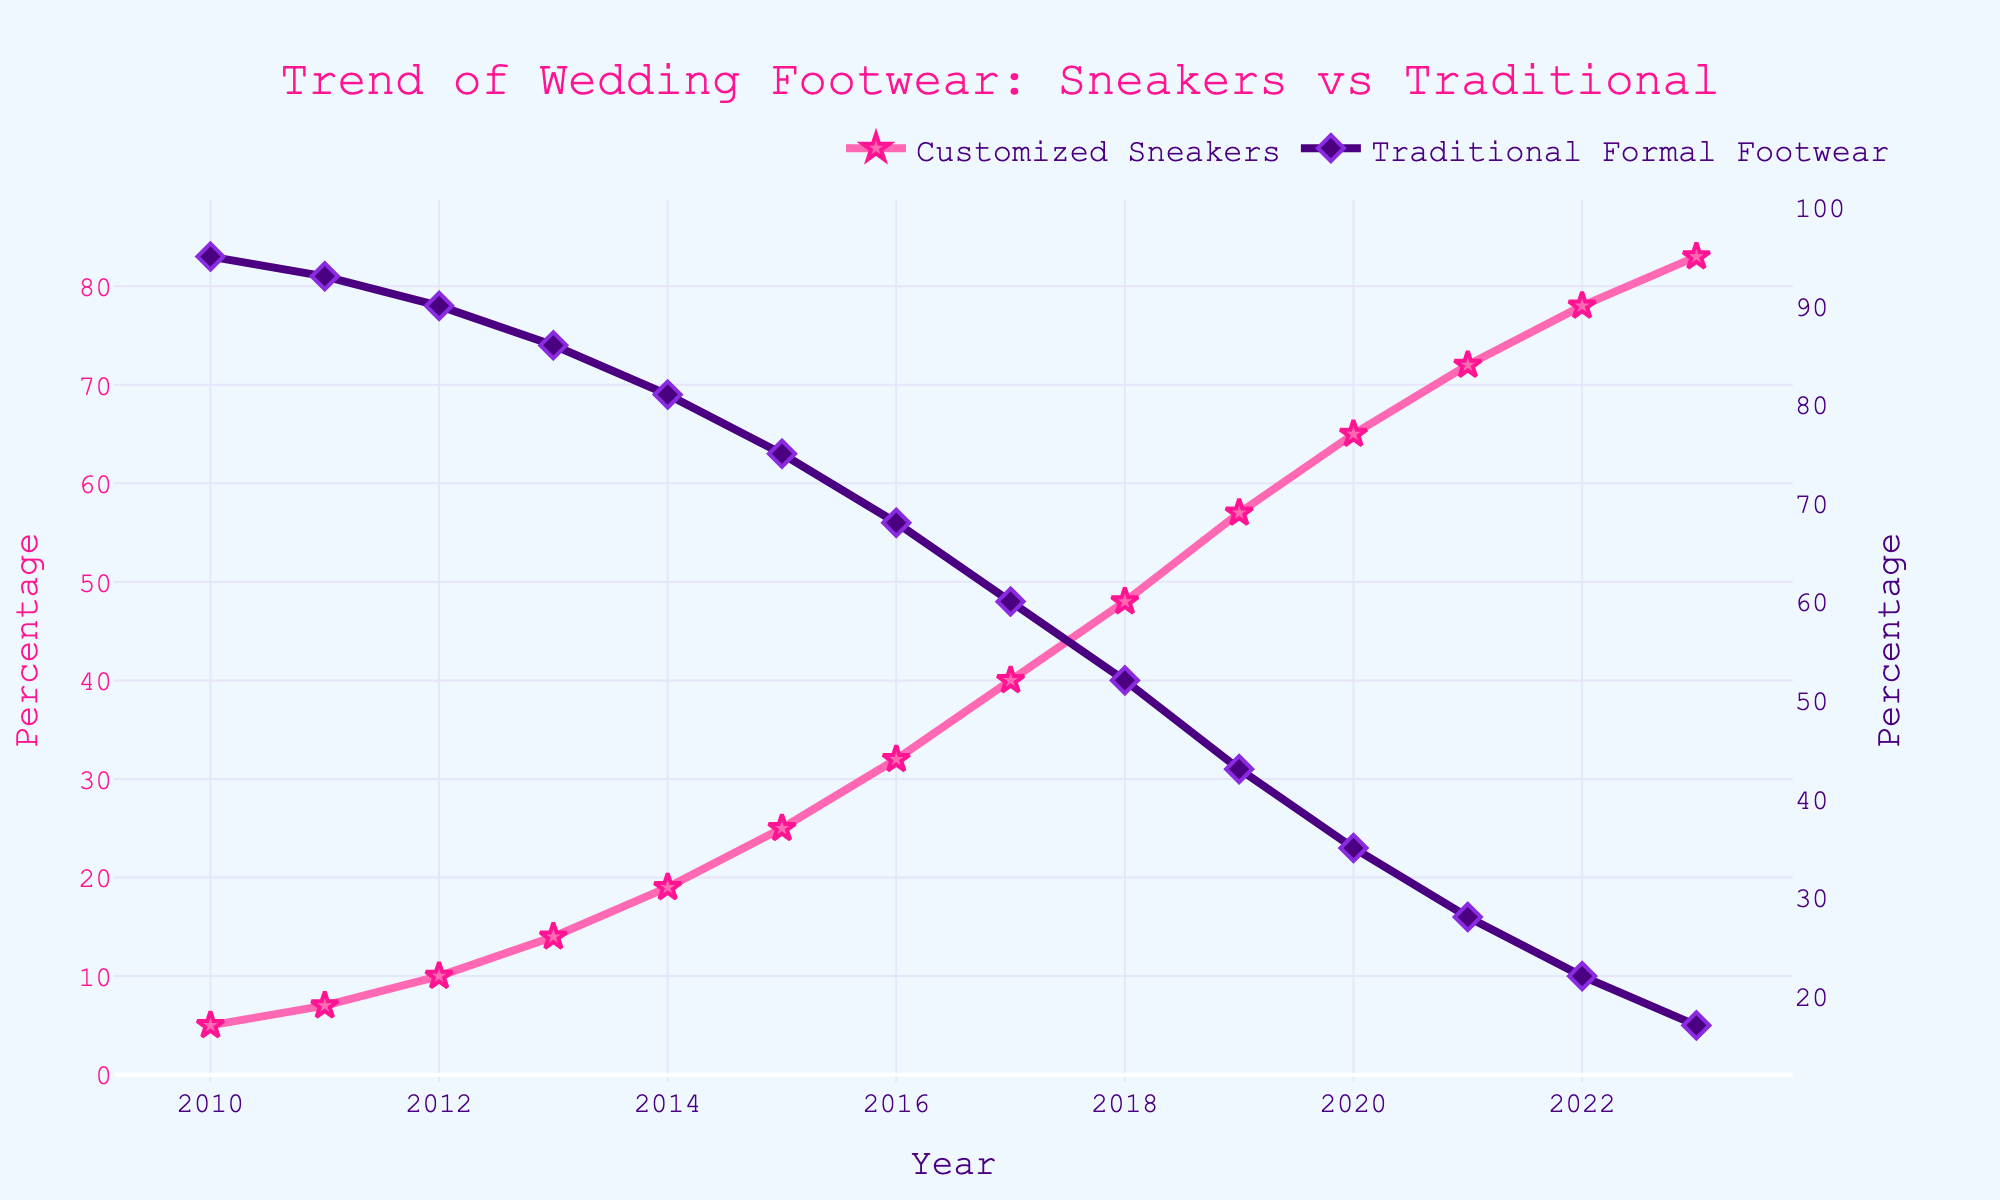what's the overall trend shown in the chart for customized sneakers and traditional formal footwear from 2010 to 2023? To determine the overall trend for both customized sneakers and traditional formal footwear, look at the direction of their respective lines. Customized sneakers show an increasing trend, while traditional formal footwear shows a decreasing trend over the years.
Answer: Increasing for sneakers, Decreasing for formal footwear how does the percentage of customized sneakers in 2013 compare with the percentage in 2023? Compare the values for 2013 and 2023 in the chart. For customized sneakers, the percentage in 2013 is 14%, and in 2023, it is 83%, which shows a significant increase.
Answer: Increased from 14% to 83% which year did customized sneakers first surpass 50% of the market share? Locate in the chart the point where the percentage for customized sneakers first exceeds 50%. This happened in the year 2018.
Answer: 2018 by how many percentage points did the sales of traditional formal footwear drop between 2010 and 2023? Subtract the percentage of traditional formal footwear sales in 2023 from that in 2010. The drop is 95% - 17% = 78 percentage points.
Answer: 78 percentage points which type of footwear showed a greater change in market share from 2010 to 2023? Calculate the difference in market share from 2010 to 2023 for both types. Customized sneakers changed from 5% to 83%, a change of 78 percentage points. Traditional formal footwear changed from 95% to 17%, also a change of 78 percentage points. Both types showed an equal change.
Answer: Both equally changed by 78 percentage points how does the trend in percentages from 2015 to 2020 for customized sneakers differ from that for traditional formal footwear? Examine the trend lines from 2015 to 2020. Customized sneakers show a consistent increase from 25% to 65%, while traditional formal footwear shows a consistent decrease from 75% to 35%.
Answer: Sneakers increased, formal footwear decreased what visual attributes distinguish the lines for customized sneakers and traditional formal footwear? Note the visual attributes: the line for customized sneakers is pink with star-shaped markers, and the line for traditional formal footwear is purple with diamond-shaped markers.
Answer: Pink with stars, Purple with diamonds what is the difference in market share percentage between customized sneakers and traditional formal footwear in 2021? Subtract the market share percentage of traditional formal footwear in 2021 from the market share percentage of customized sneakers in 2021: 72% - 28% = 44 percentage points.
Answer: 44 percentage points which footwear type showed the fastest increase or decrease in market share between any two consecutive years? Examine year-to-year changes. The fastest increase for customized sneakers happened between 2019 and 2020, from 57% to 65%, an 8 percentage points increase. The fastest decrease for traditional formal footwear is also between 2019 and 2020, from 43% to 35%, an 8 percentage points decrease.
Answer: Equal fastest change: Sneakers +8% (2019-2020), Formal footwear -8% (2019-2020) what can you infer about the overall market trend in wedding footwear preferences from the chart? Based on the consistent increase in customized sneaker sales and the consistent decline in traditional formal footwear, we can infer that there is a growing preference for customized sneakers over traditional formal footwear in wedding attire.
Answer: Growing preference for sneakers over formal footwear 